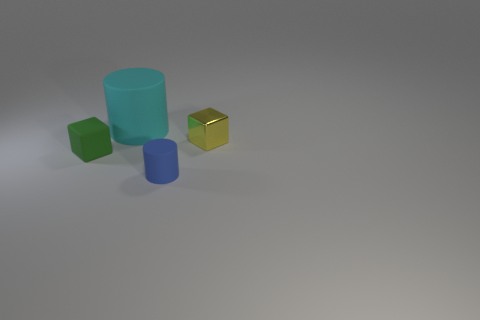What material is the small object that is the same shape as the large thing?
Ensure brevity in your answer.  Rubber. There is a small object that is to the left of the cyan cylinder; what number of small shiny cubes are on the left side of it?
Ensure brevity in your answer.  0. There is a object that is behind the block to the right of the block on the left side of the big cyan rubber cylinder; what size is it?
Your answer should be compact. Large. What is the color of the block that is left of the matte thing that is behind the metal block?
Offer a terse response. Green. How many other things are there of the same material as the tiny yellow object?
Offer a very short reply. 0. How many other things are there of the same color as the large rubber cylinder?
Keep it short and to the point. 0. There is a block that is to the right of the small matte object that is in front of the tiny green matte object; what is it made of?
Provide a succinct answer. Metal. Is there a large brown object?
Offer a very short reply. No. There is a thing that is left of the matte thing that is behind the yellow object; what size is it?
Provide a short and direct response. Small. Are there more rubber objects in front of the green block than tiny yellow objects that are to the left of the cyan matte cylinder?
Offer a terse response. Yes. 